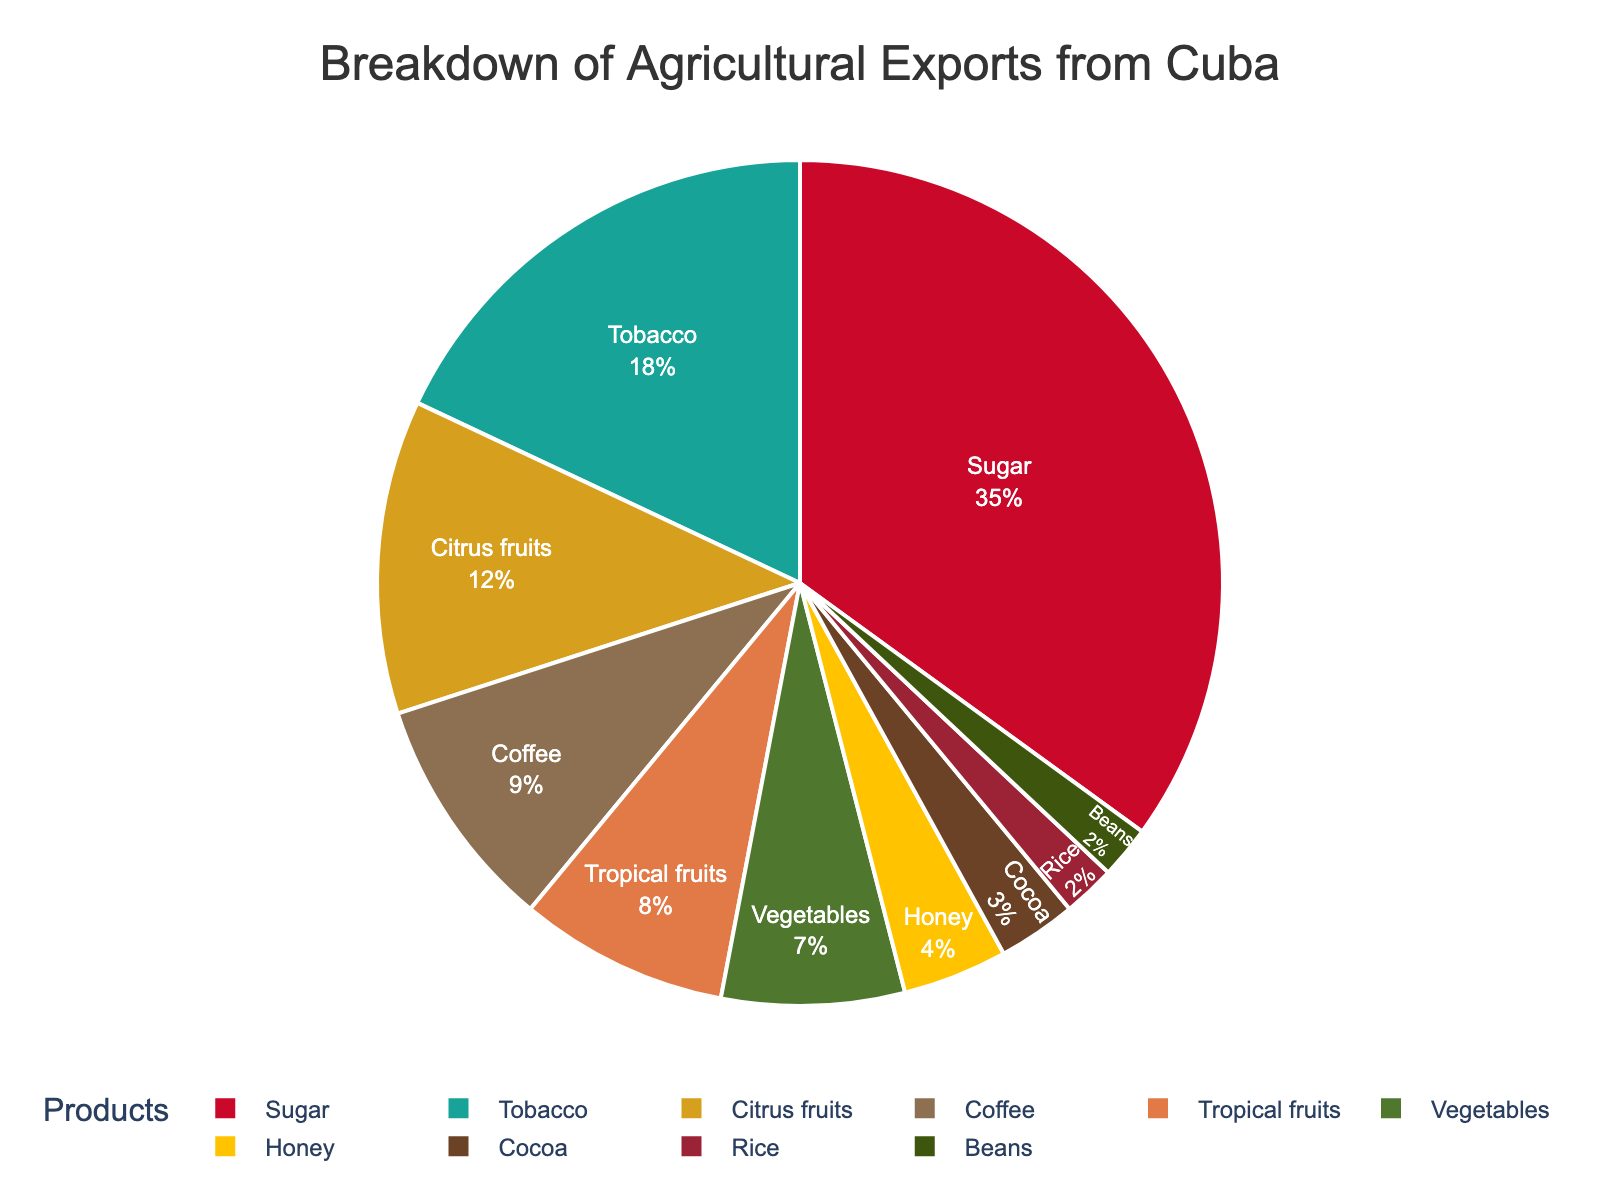Which product category has the highest percentage of agricultural exports? The pie chart shows different product categories with their percentages. The largest slice indicates the highest percentage, which is Sugar at 35%.
Answer: Sugar Which two product categories together make up just over half of the agricultural exports? Adding up the two largest percentages from the pie chart, Sugar (35%) and Tobacco (18%), gives us 53%, which is just over half.
Answer: Sugar and Tobacco What is the percentage difference between Citrus fruits and Vegetables? The chart shows that Citrus fruits have 12% and Vegetables have 7%. Subtracting these gives a difference of 5%.
Answer: 5% How do the combined exports of Honey, Cocoa, Rice, and Beans compare to Tropical fruits? Sum the percentages of Honey (4%), Cocoa (3%), Rice (2%), and Beans (2%), which equals 11%. Tropical fruits are at 8%, so the combined smaller categories exceed Tropical fruits by 3%.
Answer: 3% more How many percentage points does Coffee represent compared to the sum of Vegetables and Beans? Coffee is 9%. Vegetables and Beans together are 7% + 2%, which also equals 9%. So, Coffee represents the same percentage points as Vegetables and Beans together.
Answer: Equal, 9% Which product category has the smallest slice on the chart? The smallest slice on the chart corresponds to Beans, which is 2%.
Answer: Beans What is the percentage of agricultural exports represented by products other than Sugar and Tobacco? The combined percentage of Sugar and Tobacco is 35% + 18%, which equals 53%. Subtracting this from 100% leaves us with 47%.
Answer: 47% If you combine the exports of Tropical fruits and Coffee, how do they compare to the exports of Sugar? Tropical fruits and Coffee combined are 8% + 9%, which gives 17%. Sugar alone is 35%, so Sugar exceeds this combination by 18%.
Answer: Sugar exceeds by 18% Are there more agricultural exports in the Tropical fruits category or in the Citrus fruits category? From the pie chart, Citrus fruits have 12% and Tropical fruits have 8%. Hence, Citrus fruits have a higher percentage.
Answer: Citrus fruits What is the average percentage of Tobacco, Coffee, and Vegetables? Sum the percentages of Tobacco (18%), Coffee (9%), and Vegetables (7%), which equals 34%. The average is 34% divided by 3, which is approximately 11.33%.
Answer: 11.33% 